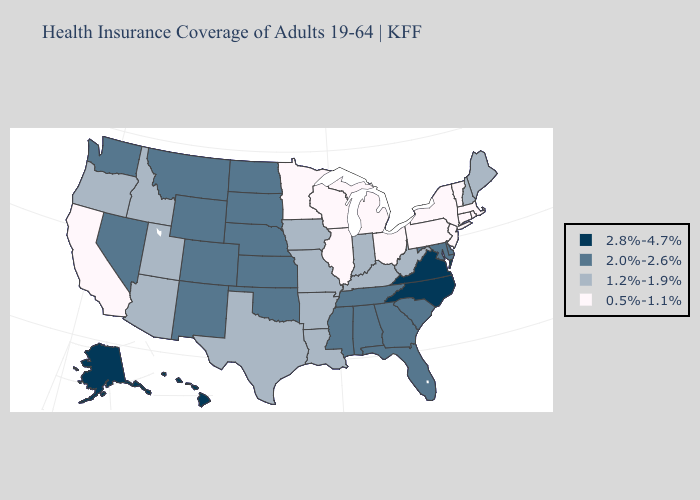What is the value of Utah?
Give a very brief answer. 1.2%-1.9%. Name the states that have a value in the range 2.0%-2.6%?
Give a very brief answer. Alabama, Colorado, Delaware, Florida, Georgia, Kansas, Maryland, Mississippi, Montana, Nebraska, Nevada, New Mexico, North Dakota, Oklahoma, South Carolina, South Dakota, Tennessee, Washington, Wyoming. What is the lowest value in states that border Missouri?
Short answer required. 0.5%-1.1%. Does Louisiana have the same value as New York?
Quick response, please. No. Which states have the highest value in the USA?
Keep it brief. Alaska, Hawaii, North Carolina, Virginia. What is the highest value in the South ?
Give a very brief answer. 2.8%-4.7%. Name the states that have a value in the range 2.0%-2.6%?
Quick response, please. Alabama, Colorado, Delaware, Florida, Georgia, Kansas, Maryland, Mississippi, Montana, Nebraska, Nevada, New Mexico, North Dakota, Oklahoma, South Carolina, South Dakota, Tennessee, Washington, Wyoming. What is the highest value in the USA?
Answer briefly. 2.8%-4.7%. What is the value of Wyoming?
Be succinct. 2.0%-2.6%. Which states have the highest value in the USA?
Quick response, please. Alaska, Hawaii, North Carolina, Virginia. Which states have the highest value in the USA?
Keep it brief. Alaska, Hawaii, North Carolina, Virginia. Among the states that border Utah , which have the highest value?
Concise answer only. Colorado, Nevada, New Mexico, Wyoming. Which states hav the highest value in the Northeast?
Answer briefly. Maine, New Hampshire. 